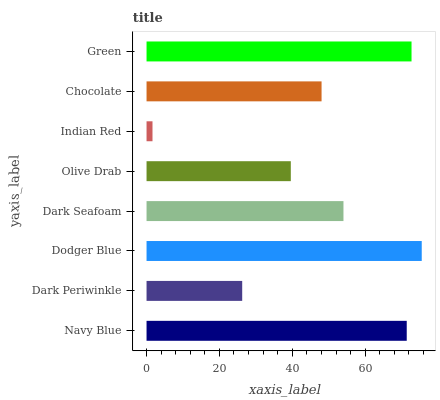Is Indian Red the minimum?
Answer yes or no. Yes. Is Dodger Blue the maximum?
Answer yes or no. Yes. Is Dark Periwinkle the minimum?
Answer yes or no. No. Is Dark Periwinkle the maximum?
Answer yes or no. No. Is Navy Blue greater than Dark Periwinkle?
Answer yes or no. Yes. Is Dark Periwinkle less than Navy Blue?
Answer yes or no. Yes. Is Dark Periwinkle greater than Navy Blue?
Answer yes or no. No. Is Navy Blue less than Dark Periwinkle?
Answer yes or no. No. Is Dark Seafoam the high median?
Answer yes or no. Yes. Is Chocolate the low median?
Answer yes or no. Yes. Is Chocolate the high median?
Answer yes or no. No. Is Green the low median?
Answer yes or no. No. 